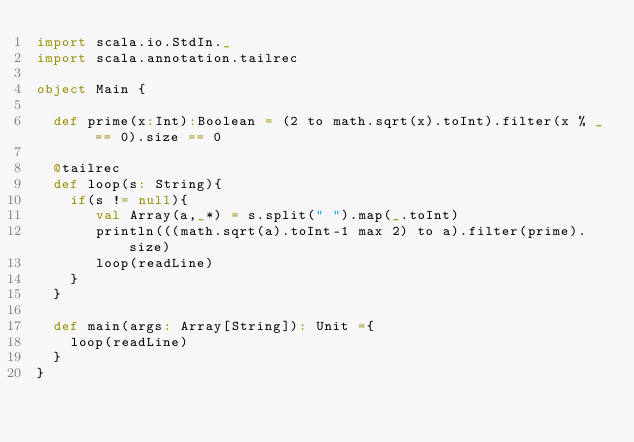<code> <loc_0><loc_0><loc_500><loc_500><_Scala_>import scala.io.StdIn._
import scala.annotation.tailrec

object Main {

  def prime(x:Int):Boolean = (2 to math.sqrt(x).toInt).filter(x % _ == 0).size == 0

  @tailrec
  def loop(s: String){
    if(s != null){
       val Array(a,_*) = s.split(" ").map(_.toInt)
       println(((math.sqrt(a).toInt-1 max 2) to a).filter(prime).size)
       loop(readLine)
    }
  }

  def main(args: Array[String]): Unit ={
    loop(readLine)
  }
}</code> 